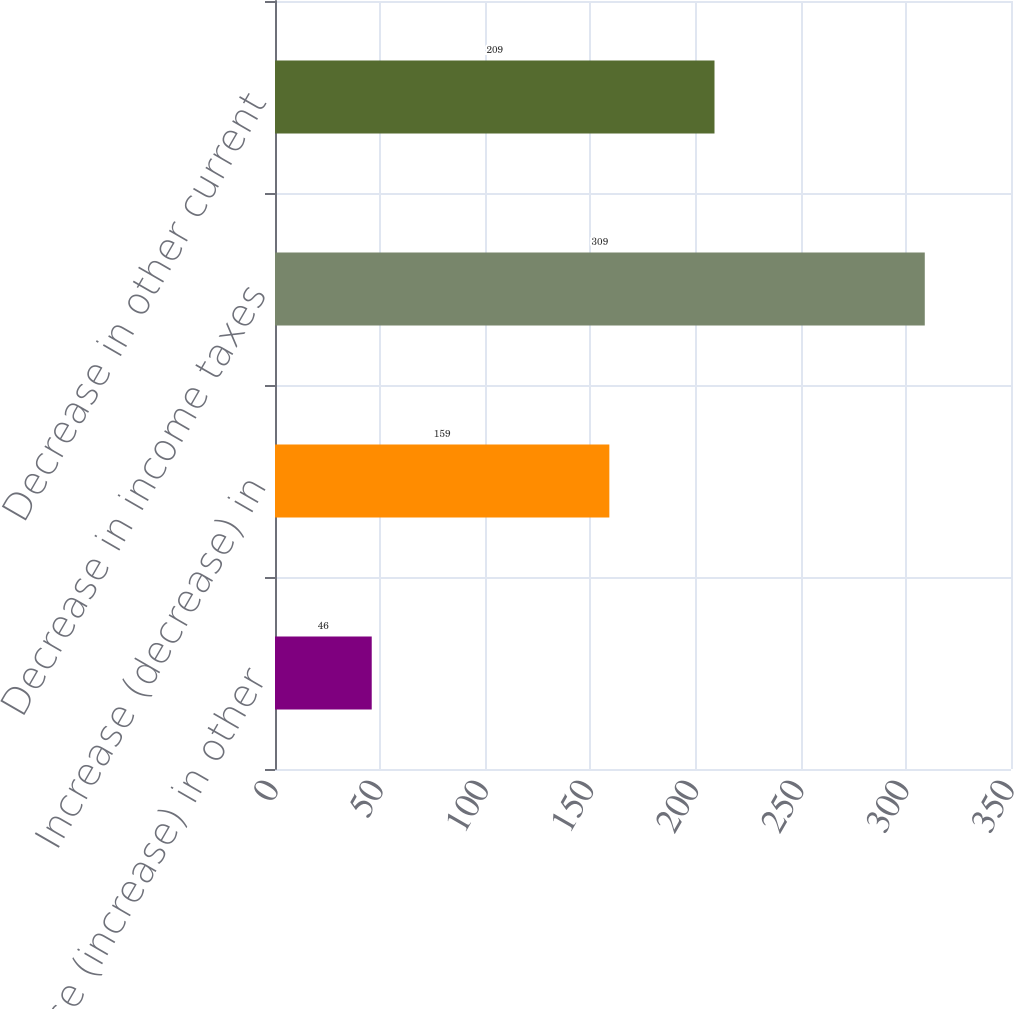<chart> <loc_0><loc_0><loc_500><loc_500><bar_chart><fcel>Decrease (increase) in other<fcel>Increase (decrease) in<fcel>Decrease in income taxes<fcel>Decrease in other current<nl><fcel>46<fcel>159<fcel>309<fcel>209<nl></chart> 